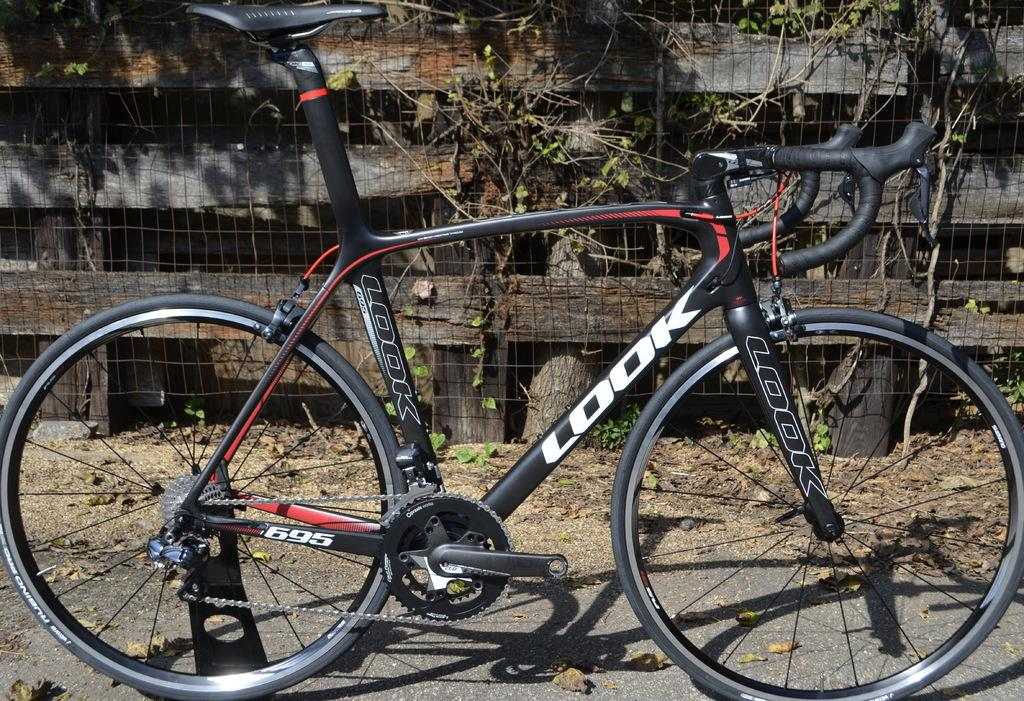What is the main subject in the center of the image? There is a bicycle in the center of the image. What color is the bicycle? The bicycle is black in color. What can be seen in the background of the image? There is a boundary in the background area of the image. Can you describe the scene of the turkey crossing the bridge in the image? There is no scene of a turkey crossing a bridge in the image; it features a black bicycle in the center and a boundary in the background. 